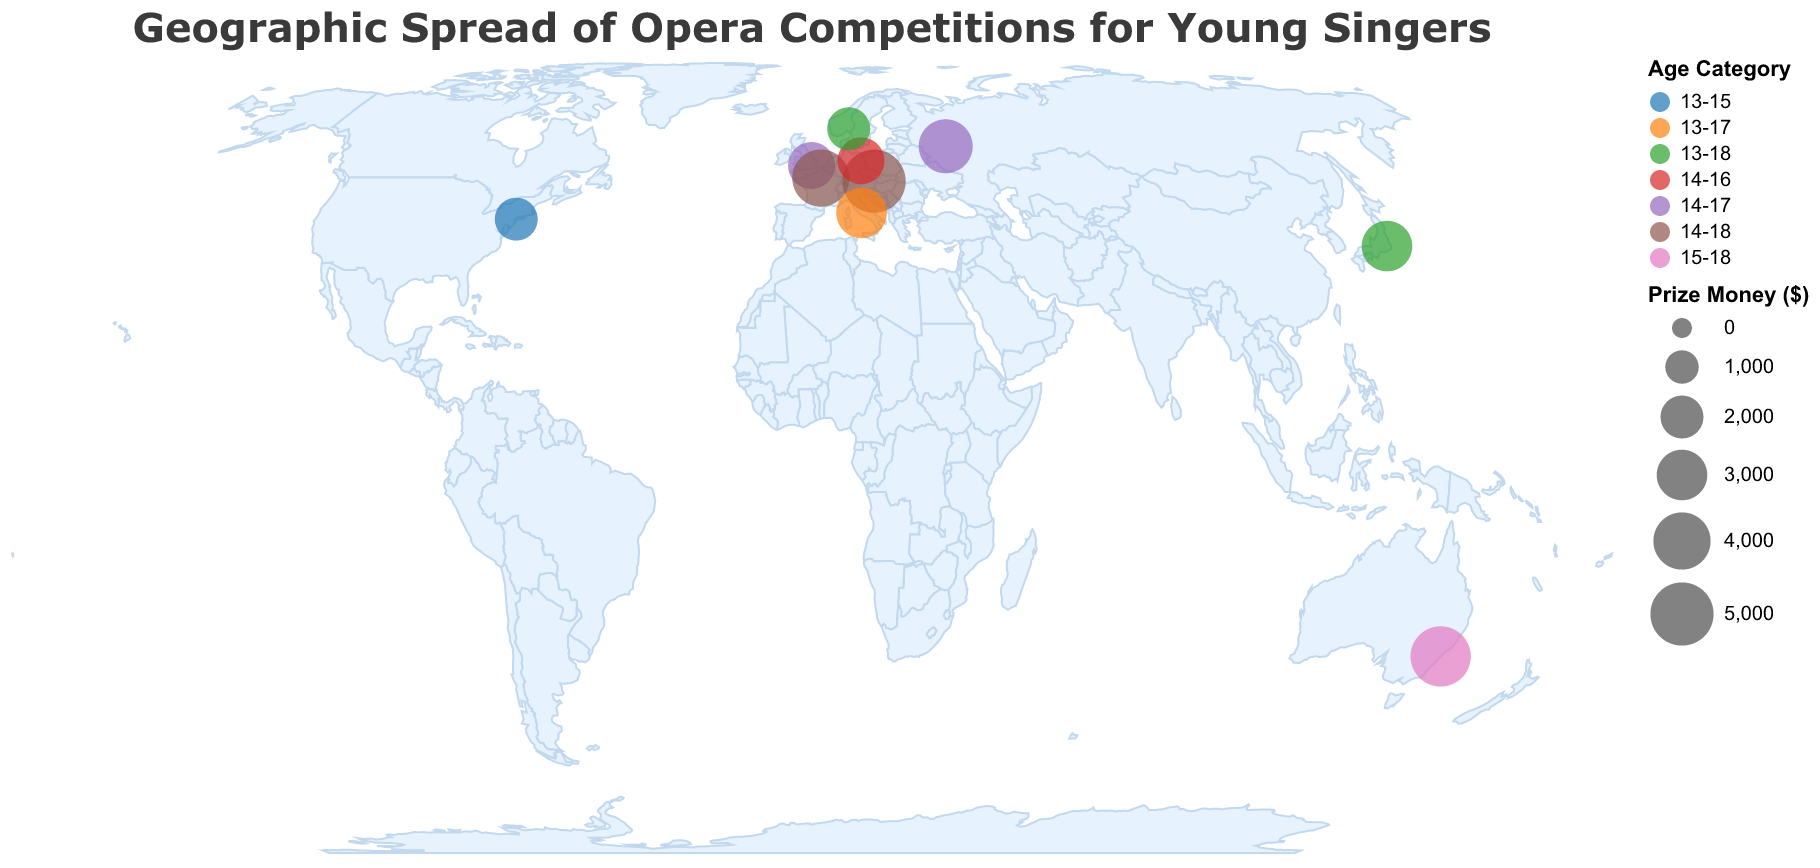What is the title of the figure? The title of the figure is usually written at the top of the chart. In this case, it states "Geographic Spread of Opera Competitions for Young Singers"
Answer: Geographic Spread of Opera Competitions for Young Singers Which city hosts the Belvedere Singing Competition? Each data point on the map has a tooltip showing the corresponding city. For the Belvedere Singing Competition, the city is Vienna.
Answer: Vienna How many competitions have a prize money of more than $4000? By analyzing the size of the circles and referring to the tooltip, we can see that the Belvedere Singing Competition and Sydney Eisteddfod Opera Scholarship have prize money greater than $4000.
Answer: 2 Which competition offers the highest prize money? Looking at the size of the circles, the largest one corresponds to the Belvedere Singing Competition with $5000 in prize money.
Answer: Belvedere Singing Competition What age categories are represented in the figure? The colors of the circles represent different age categories, and the legend shows these categories. The age categories are 13-15, 13-17, 13-18, 14-16, 14-17, and 14-18.
Answer: 13-15, 13-17, 13-18, 14-16, 14-17, 14-18 Which country has the most competitions shown on the map? By counting the number of circles per country, we find that each country has one competition listed; therefore, there is no single country with more than one competition.
Answer: No country has more than one competition What's the prize money range for competitions in Europe? The European competitions shown are in Vienna, Rome, London, Paris, Berlin, and Moscow. Their prize money is $5000, $3000, $2500, $4000, $2500, and $3500, giving a range from $2500 to $5000.
Answer: $2500 to $5000 Which competition has the smallest age category range? The tooltip and data indicate that the Hal Leonard Vocal Competition in New York has the smallest age category range of 13-15.
Answer: Hal Leonard Vocal Competition How does the prize money for the Tokyo International Vocal Competition compare to that of the Paris Opera Young Artists Program? Checking the tooltips for each, the Tokyo International Vocal Competition has a prize money of $3000, while the Paris Opera Young Artists Program offers $4000.
Answer: The Tokyo competition has $1000 less than the Paris competition What is the average prize money for all the competitions? Adding up all the prize money: 5000 + 3000 + 2500 + 2000 + 4000 + 3500 + 3000 + 2500 + 2000 + 4500, which equals 32000. There are 10 competitions, so the average is 32000 / 10.
Answer: $3200 